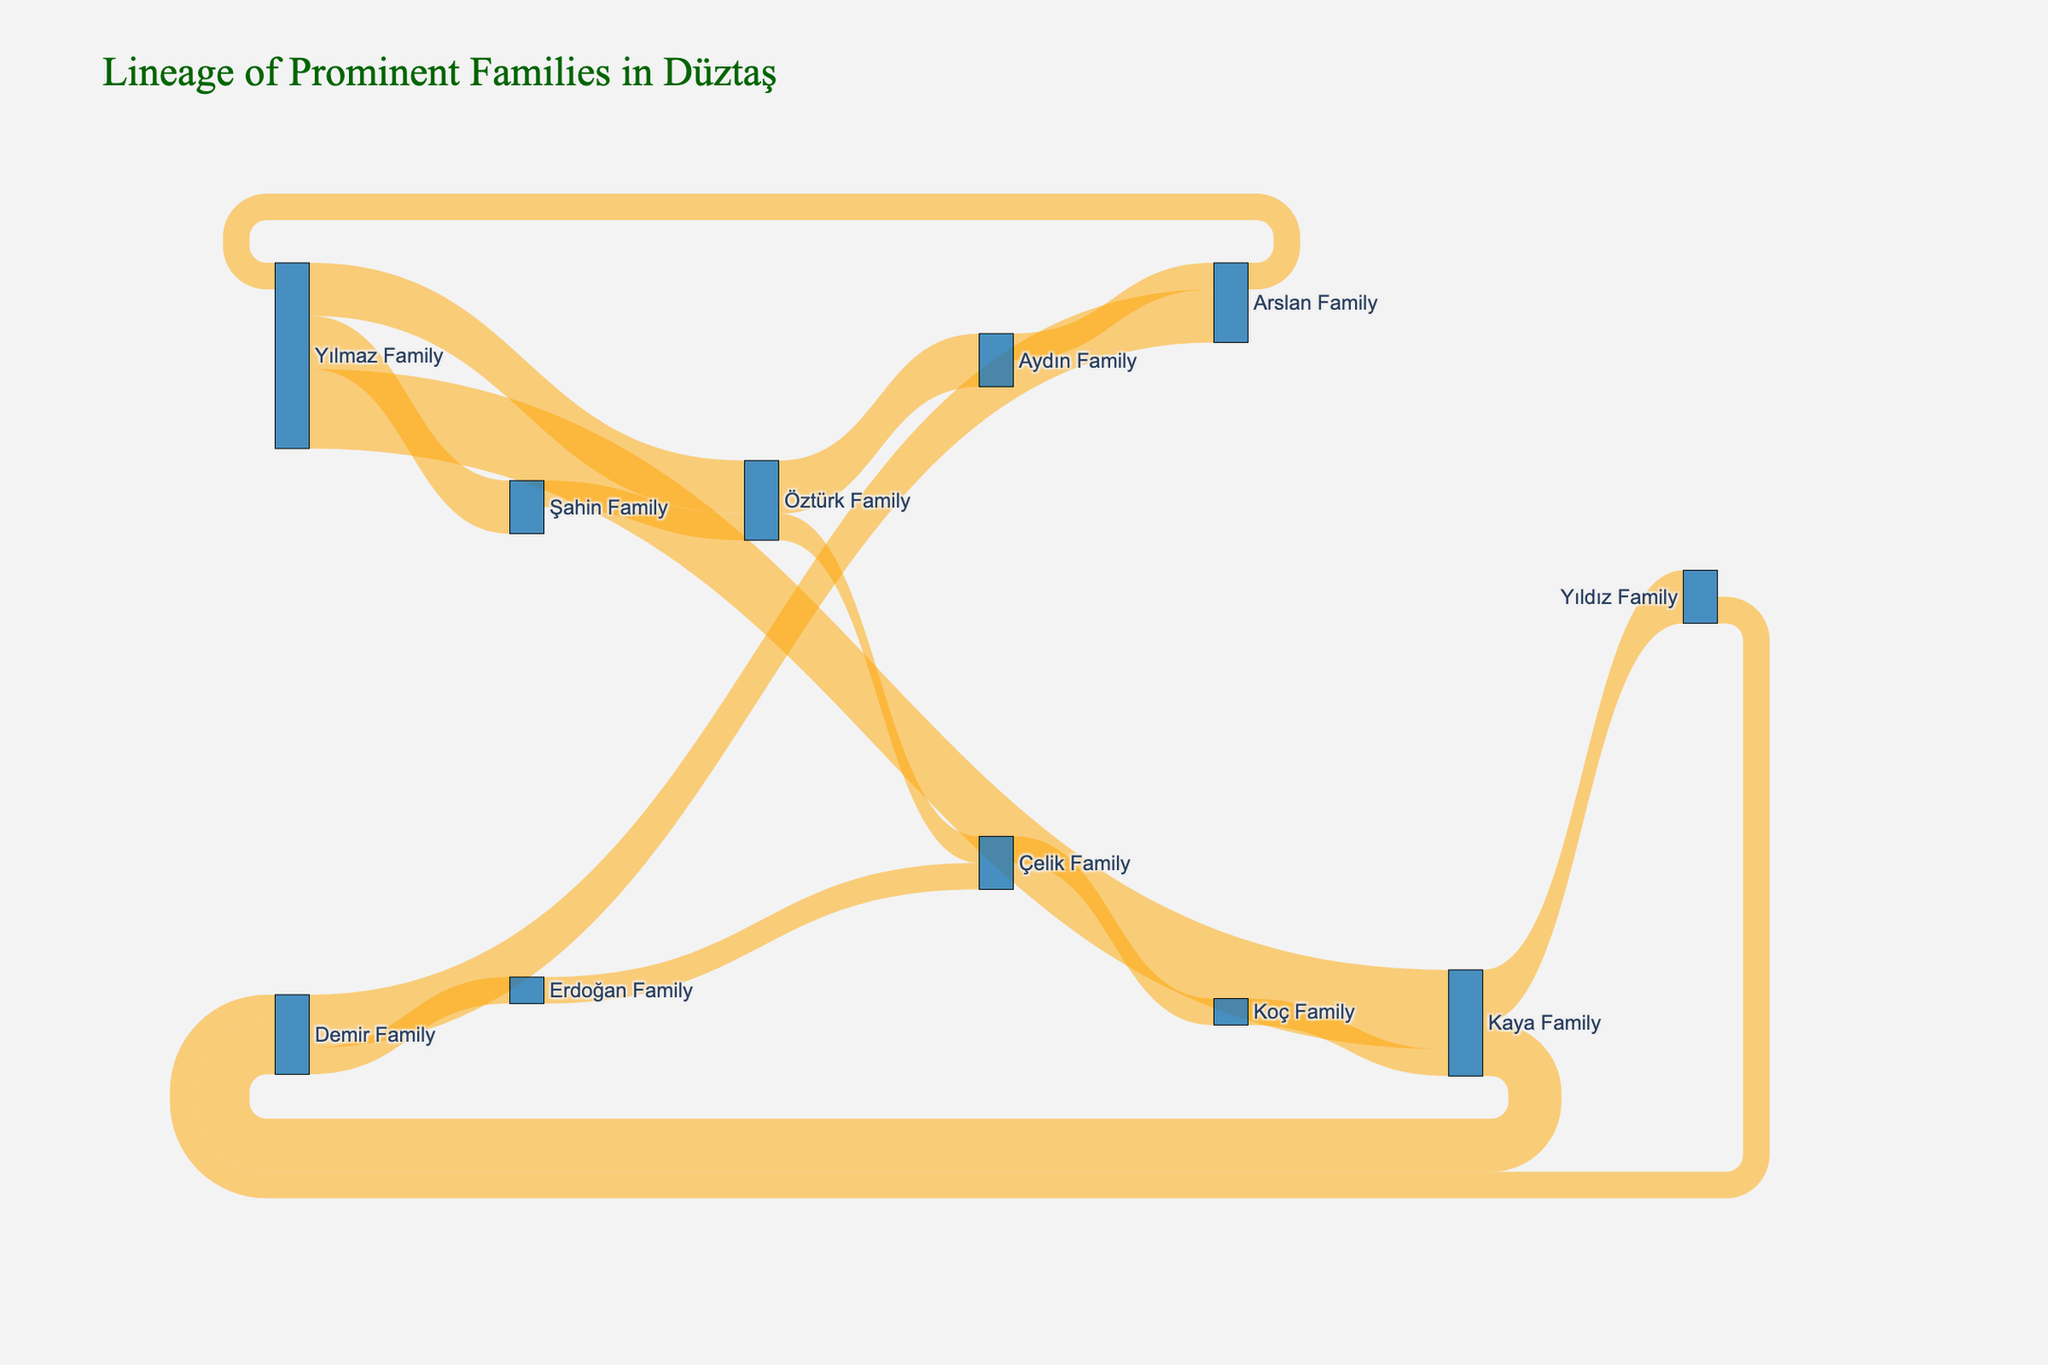Which family is at the starting point of the most connections? The Yılmaz Family has connections to the Kaya Family, Öztürk Family, and Şahin Family, making it the starting point of 3 connections.
Answer: Yılmaz Family What is the total number of connections originating from the Kaya Family? The Kaya Family has connections to the Demir Family and Yıldız Family, totaling 2 connections.
Answer: 2 Which family does the Çelik Family connect to, and with how many connections? The Çelik Family connects to the Koç Family with 1 connection.
Answer: Koç Family, 1 How many connections end with the Demir Family? The Demir Family receives connections from the Kaya Family, resulting in 2 connections.
Answer: 2 Which two families have a single connection linking them directly? The Yılmaz Family and the Öztürk Family are connected directly with a single connection.
Answer: Yılmaz Family and Öztürk Family What is the total number of connections involving the Arslan Family? The Arslan Family has two connections involving them: one from the Demir Family and another from the Aydın Family.
Answer: 2 Compare the connections between the Yılmaz Family and the Kaya Family. Who has more? The Yılmaz Family has 3 connections originating from it, while the Kaya Family has 2 connections. Therefore, the Yılmaz Family has more connections.
Answer: Yılmaz Family Which family is connected to the most other families through direct connections? The Yılmaz Family connects to three different families (Kaya, Öztürk, and Şahin), making the most connections to other families.
Answer: Yılmaz Family How many families are connected to the Yıldız Family? The Yıldız Family has one connection from the Kaya Family.
Answer: 1 